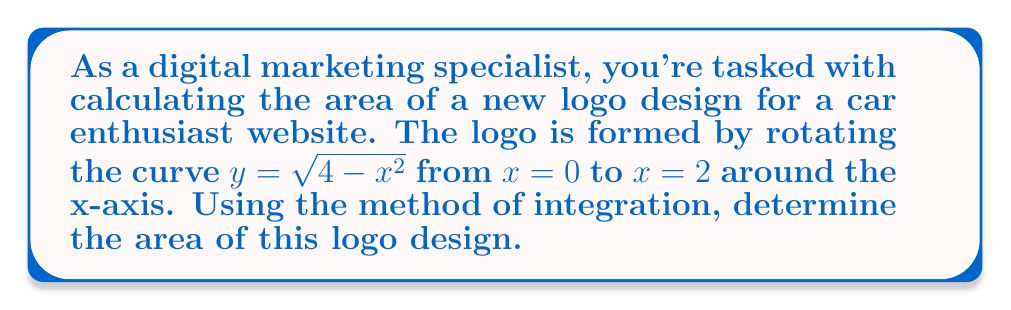Help me with this question. Let's approach this step-by-step:

1) The logo is formed by rotating a curve around the x-axis. This creates a solid of revolution, and we can use the washer method to calculate its volume, which in this case represents the area of our 2D logo.

2) The washer method formula is:

   $$V = \pi \int_a^b [R(x)^2 - r(x)^2] dx$$

   where $R(x)$ is the outer radius function and $r(x)$ is the inner radius function.

3) In our case:
   - $R(x) = \sqrt{4-x^2}$ (the given curve)
   - $r(x) = 0$ (we're rotating around the x-axis)
   - $a = 0$ and $b = 2$ (the given interval)

4) Substituting these into our formula:

   $$V = \pi \int_0^2 [(\sqrt{4-x^2})^2 - 0^2] dx$$

5) Simplify:

   $$V = \pi \int_0^2 (4-x^2) dx$$

6) Integrate:

   $$V = \pi [4x - \frac{1}{3}x^3]_0^2$$

7) Evaluate the definite integral:

   $$V = \pi [(8 - \frac{8}{3}) - (0 - 0)]$$
   $$V = \pi [\frac{24}{3} - \frac{8}{3}]$$
   $$V = \pi [\frac{16}{3}]$$
   $$V = \frac{16\pi}{3}$$

This volume represents the area of our 2D logo.
Answer: $\frac{16\pi}{3}$ square units 